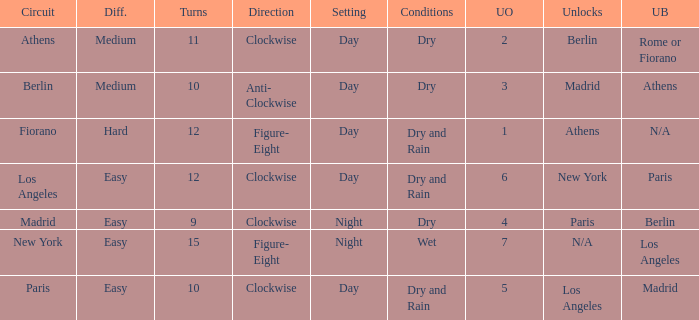How many instances is paris the unlock? 1.0. 